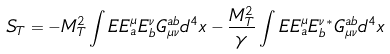Convert formula to latex. <formula><loc_0><loc_0><loc_500><loc_500>S _ { T } = - M _ { T } ^ { 2 } \int E E _ { a } ^ { \mu } E _ { b } ^ { \nu } G ^ { a b } _ { \mu \nu } d ^ { 4 } x - \frac { M _ { T } ^ { 2 } } { \gamma } \int E E _ { a } ^ { \mu } E _ { b } ^ { \nu } { ^ { * } } G ^ { a b } _ { \mu \nu } d ^ { 4 } x</formula> 